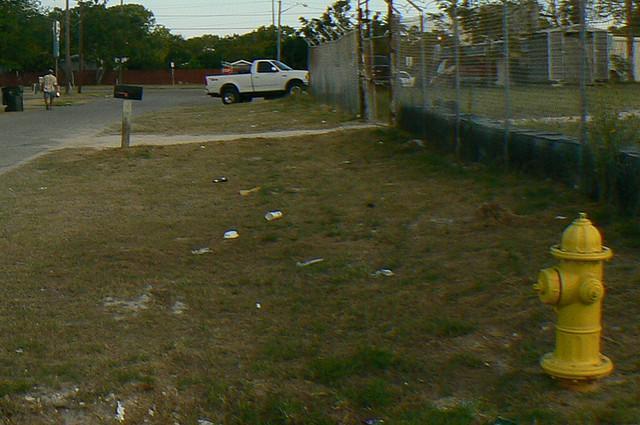How many people can be seen?
Give a very brief answer. 1. 